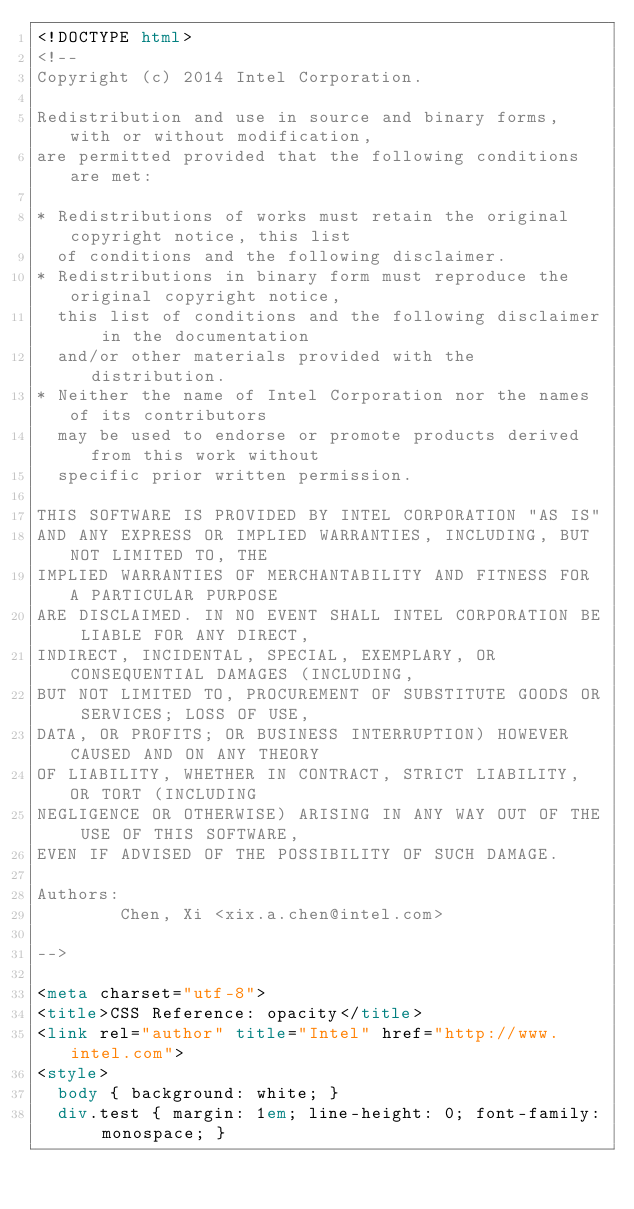<code> <loc_0><loc_0><loc_500><loc_500><_HTML_><!DOCTYPE html>
<!--
Copyright (c) 2014 Intel Corporation.

Redistribution and use in source and binary forms, with or without modification,
are permitted provided that the following conditions are met:

* Redistributions of works must retain the original copyright notice, this list
  of conditions and the following disclaimer.
* Redistributions in binary form must reproduce the original copyright notice,
  this list of conditions and the following disclaimer in the documentation
  and/or other materials provided with the distribution.
* Neither the name of Intel Corporation nor the names of its contributors
  may be used to endorse or promote products derived from this work without
  specific prior written permission.

THIS SOFTWARE IS PROVIDED BY INTEL CORPORATION "AS IS"
AND ANY EXPRESS OR IMPLIED WARRANTIES, INCLUDING, BUT NOT LIMITED TO, THE
IMPLIED WARRANTIES OF MERCHANTABILITY AND FITNESS FOR A PARTICULAR PURPOSE
ARE DISCLAIMED. IN NO EVENT SHALL INTEL CORPORATION BE LIABLE FOR ANY DIRECT,
INDIRECT, INCIDENTAL, SPECIAL, EXEMPLARY, OR CONSEQUENTIAL DAMAGES (INCLUDING,
BUT NOT LIMITED TO, PROCUREMENT OF SUBSTITUTE GOODS OR SERVICES; LOSS OF USE,
DATA, OR PROFITS; OR BUSINESS INTERRUPTION) HOWEVER CAUSED AND ON ANY THEORY
OF LIABILITY, WHETHER IN CONTRACT, STRICT LIABILITY, OR TORT (INCLUDING
NEGLIGENCE OR OTHERWISE) ARISING IN ANY WAY OUT OF THE USE OF THIS SOFTWARE,
EVEN IF ADVISED OF THE POSSIBILITY OF SUCH DAMAGE.

Authors:
        Chen, Xi <xix.a.chen@intel.com>

-->

<meta charset="utf-8">
<title>CSS Reference: opacity</title>
<link rel="author" title="Intel" href="http://www.intel.com">
<style>
  body { background: white; }
  div.test { margin: 1em; line-height: 0; font-family: monospace; }</code> 